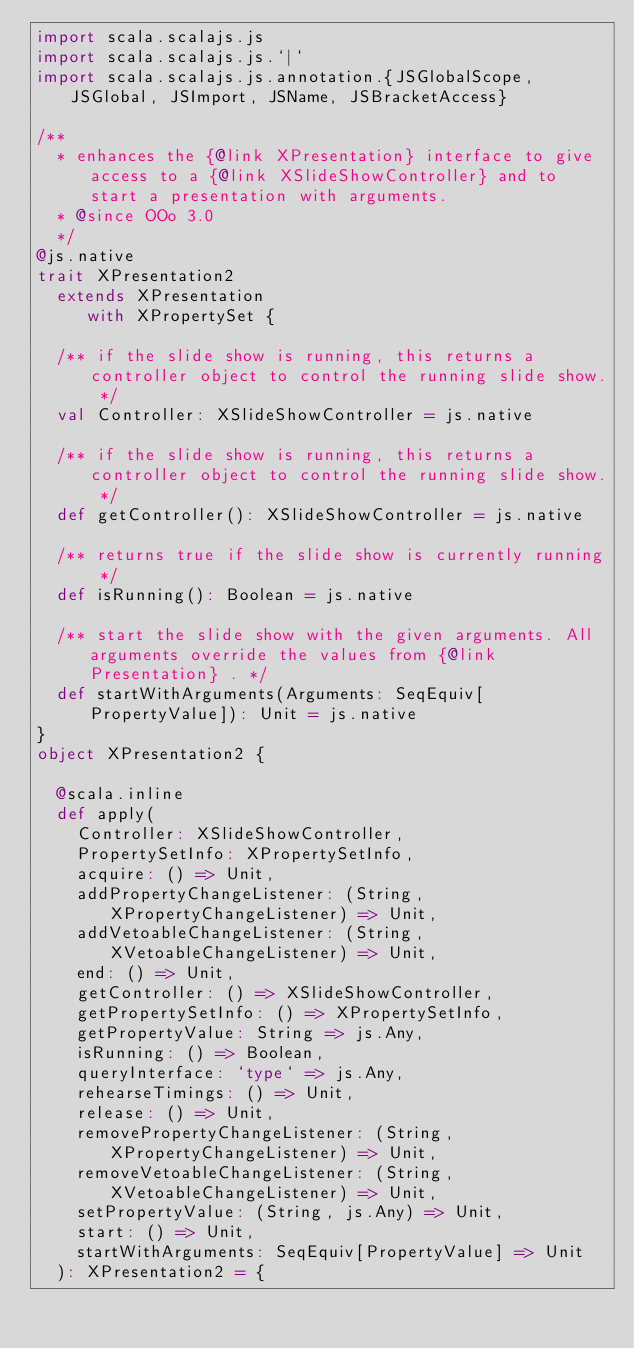Convert code to text. <code><loc_0><loc_0><loc_500><loc_500><_Scala_>import scala.scalajs.js
import scala.scalajs.js.`|`
import scala.scalajs.js.annotation.{JSGlobalScope, JSGlobal, JSImport, JSName, JSBracketAccess}

/**
  * enhances the {@link XPresentation} interface to give access to a {@link XSlideShowController} and to start a presentation with arguments.
  * @since OOo 3.0
  */
@js.native
trait XPresentation2
  extends XPresentation
     with XPropertySet {
  
  /** if the slide show is running, this returns a controller object to control the running slide show. */
  val Controller: XSlideShowController = js.native
  
  /** if the slide show is running, this returns a controller object to control the running slide show. */
  def getController(): XSlideShowController = js.native
  
  /** returns true if the slide show is currently running */
  def isRunning(): Boolean = js.native
  
  /** start the slide show with the given arguments. All arguments override the values from {@link Presentation} . */
  def startWithArguments(Arguments: SeqEquiv[PropertyValue]): Unit = js.native
}
object XPresentation2 {
  
  @scala.inline
  def apply(
    Controller: XSlideShowController,
    PropertySetInfo: XPropertySetInfo,
    acquire: () => Unit,
    addPropertyChangeListener: (String, XPropertyChangeListener) => Unit,
    addVetoableChangeListener: (String, XVetoableChangeListener) => Unit,
    end: () => Unit,
    getController: () => XSlideShowController,
    getPropertySetInfo: () => XPropertySetInfo,
    getPropertyValue: String => js.Any,
    isRunning: () => Boolean,
    queryInterface: `type` => js.Any,
    rehearseTimings: () => Unit,
    release: () => Unit,
    removePropertyChangeListener: (String, XPropertyChangeListener) => Unit,
    removeVetoableChangeListener: (String, XVetoableChangeListener) => Unit,
    setPropertyValue: (String, js.Any) => Unit,
    start: () => Unit,
    startWithArguments: SeqEquiv[PropertyValue] => Unit
  ): XPresentation2 = {</code> 